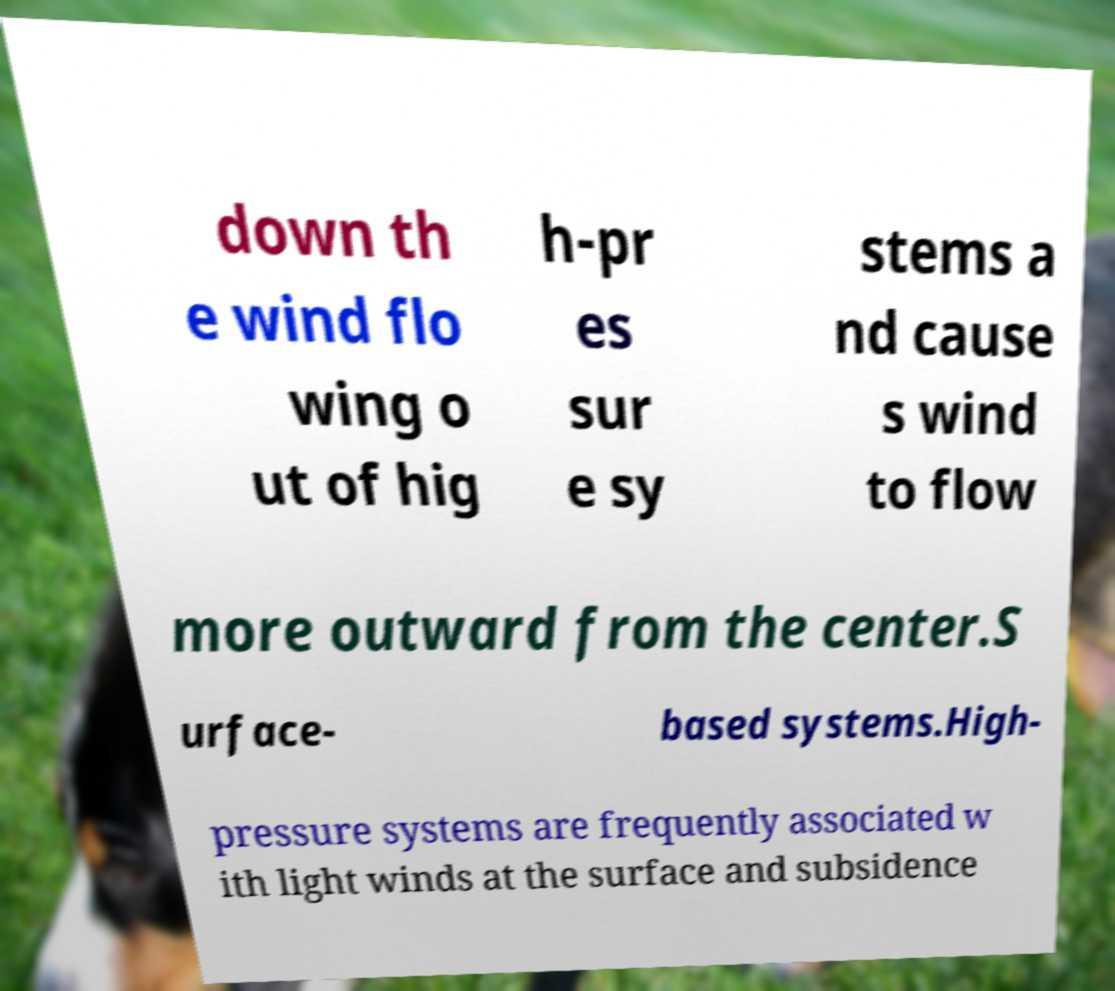Please read and relay the text visible in this image. What does it say? down th e wind flo wing o ut of hig h-pr es sur e sy stems a nd cause s wind to flow more outward from the center.S urface- based systems.High- pressure systems are frequently associated w ith light winds at the surface and subsidence 